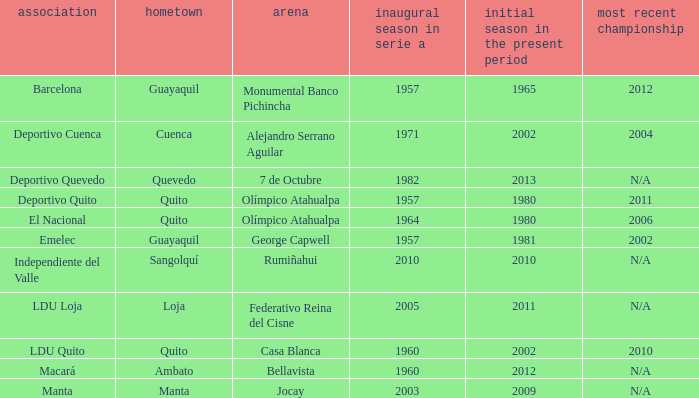Parse the table in full. {'header': ['association', 'hometown', 'arena', 'inaugural season in serie a', 'initial season in the present period', 'most recent championship'], 'rows': [['Barcelona', 'Guayaquil', 'Monumental Banco Pichincha', '1957', '1965', '2012'], ['Deportivo Cuenca', 'Cuenca', 'Alejandro Serrano Aguilar', '1971', '2002', '2004'], ['Deportivo Quevedo', 'Quevedo', '7 de Octubre', '1982', '2013', 'N/A'], ['Deportivo Quito', 'Quito', 'Olímpico Atahualpa', '1957', '1980', '2011'], ['El Nacional', 'Quito', 'Olímpico Atahualpa', '1964', '1980', '2006'], ['Emelec', 'Guayaquil', 'George Capwell', '1957', '1981', '2002'], ['Independiente del Valle', 'Sangolquí', 'Rumiñahui', '2010', '2010', 'N/A'], ['LDU Loja', 'Loja', 'Federativo Reina del Cisne', '2005', '2011', 'N/A'], ['LDU Quito', 'Quito', 'Casa Blanca', '1960', '2002', '2010'], ['Macará', 'Ambato', 'Bellavista', '1960', '2012', 'N/A'], ['Manta', 'Manta', 'Jocay', '2003', '2009', 'N/A']]} Name the last title for cuenca 2004.0. 